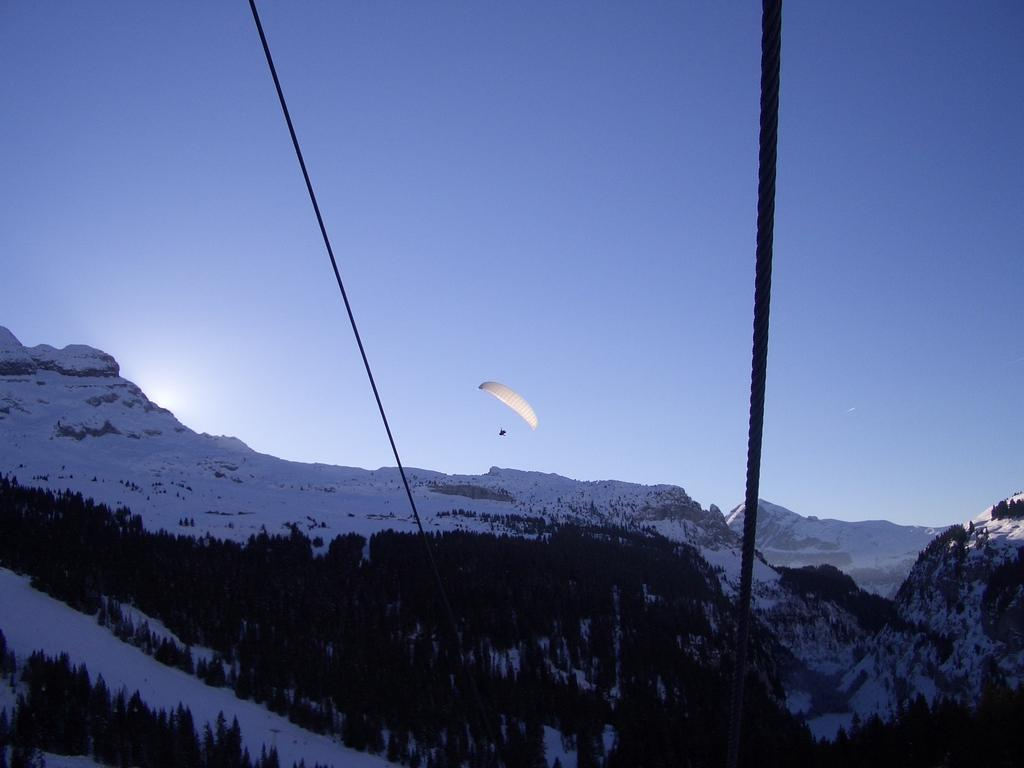What type of vegetation can be seen in the image? There are trees in the image. What objects are related to climbing or suspension in the image? There are ropes in the image. What is the large, fabric object in the image? There is a parachute in the image. What type of geographical feature is visible in the image? There are mountains in the image. What is the weather condition in the image? There is snow visible in the image, indicating a cold or snowy condition. What type of wax can be seen melting on the parachute in the image? There is no wax present in the image; it features a parachute, trees, ropes, mountains, and snow. How does the design of the trees contribute to the overall aesthetic of the image? The trees do not contribute to the overall aesthetic of the image in terms of design, as the focus is on the parachute, ropes, mountains, and snow. 